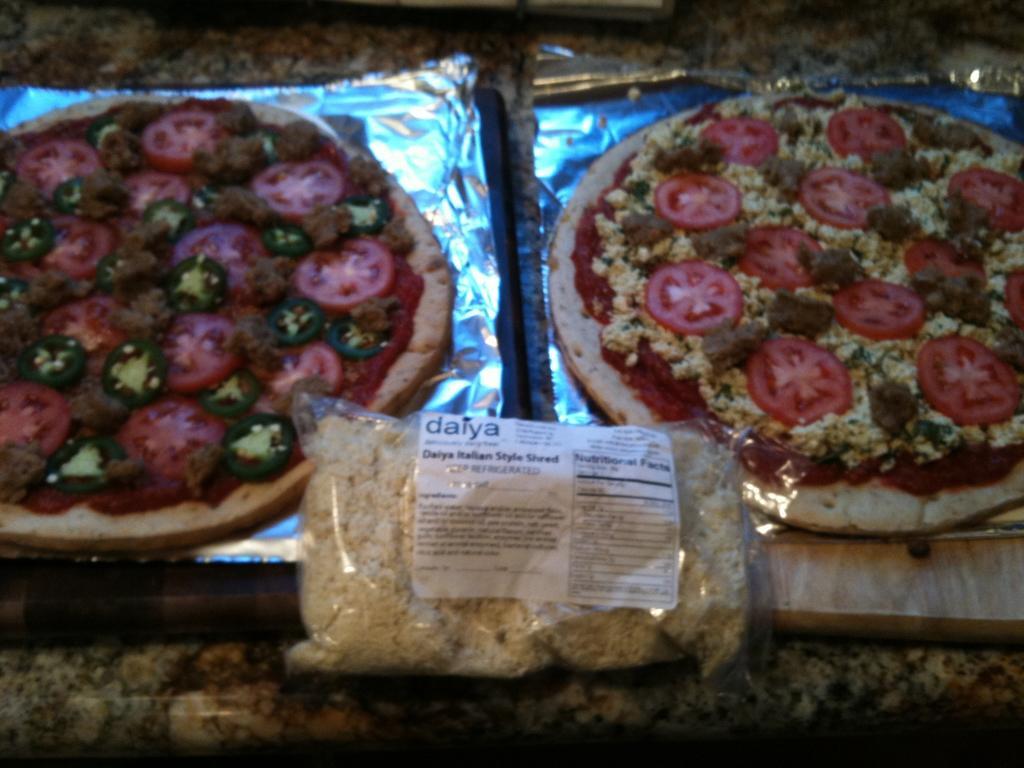Please provide a concise description of this image. In this picture we can see pizzas and some food in the plastic cover. 